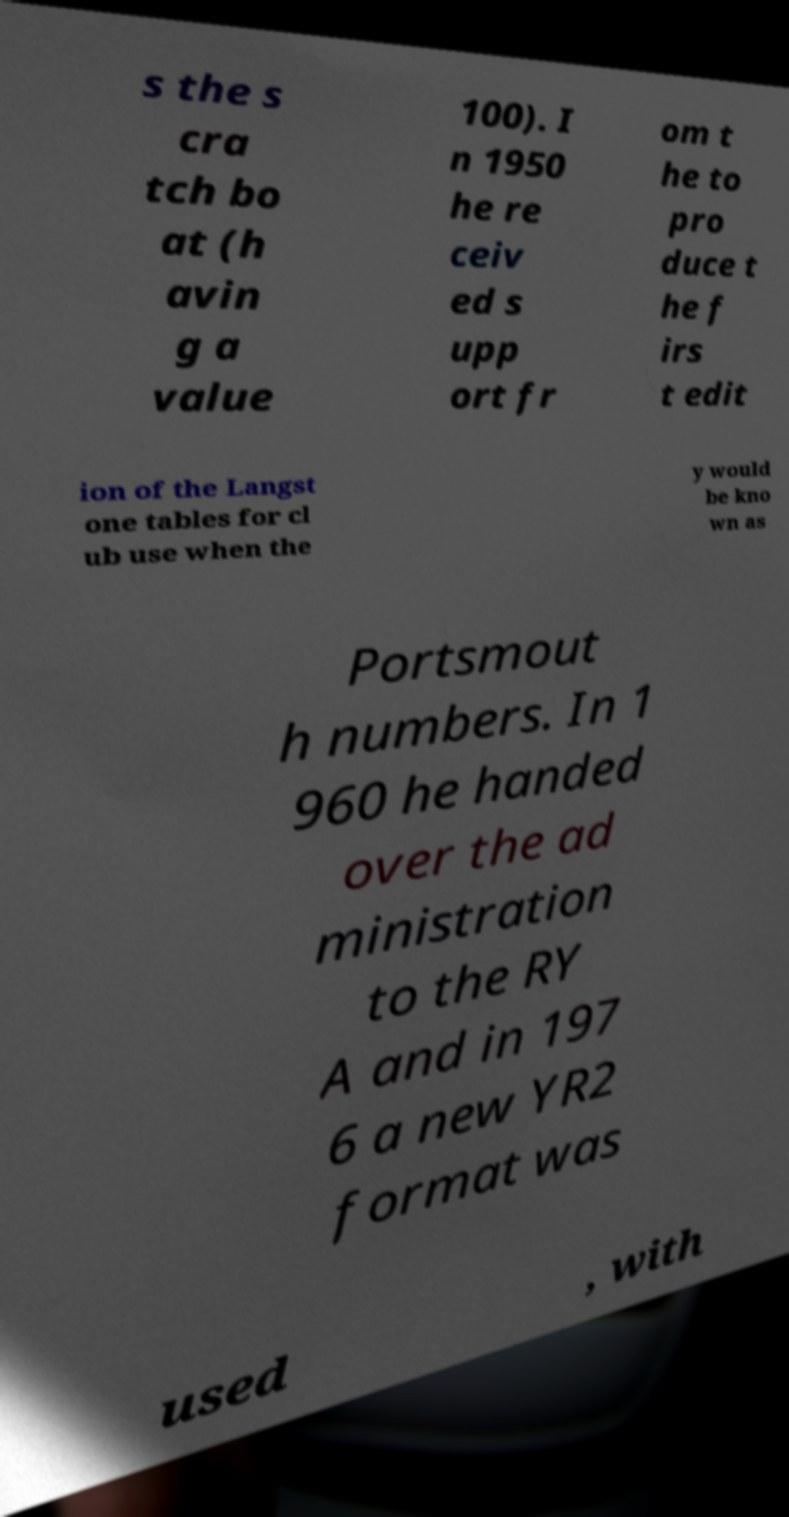Can you accurately transcribe the text from the provided image for me? s the s cra tch bo at (h avin g a value 100). I n 1950 he re ceiv ed s upp ort fr om t he to pro duce t he f irs t edit ion of the Langst one tables for cl ub use when the y would be kno wn as Portsmout h numbers. In 1 960 he handed over the ad ministration to the RY A and in 197 6 a new YR2 format was used , with 